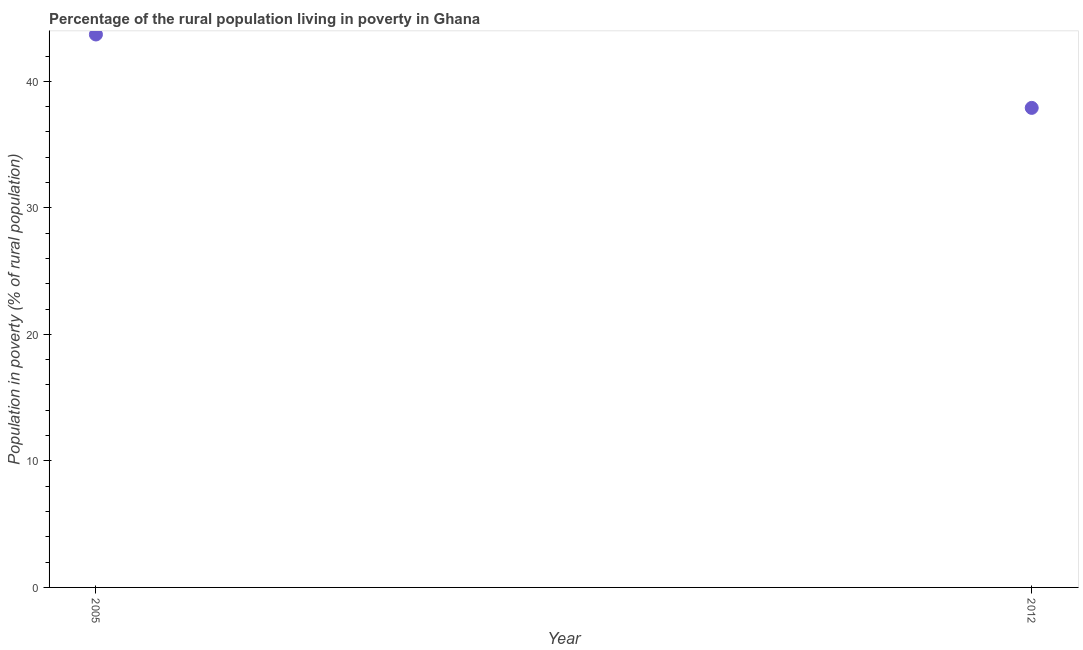What is the percentage of rural population living below poverty line in 2005?
Make the answer very short. 43.7. Across all years, what is the maximum percentage of rural population living below poverty line?
Provide a short and direct response. 43.7. Across all years, what is the minimum percentage of rural population living below poverty line?
Keep it short and to the point. 37.9. In which year was the percentage of rural population living below poverty line maximum?
Your answer should be very brief. 2005. In which year was the percentage of rural population living below poverty line minimum?
Keep it short and to the point. 2012. What is the sum of the percentage of rural population living below poverty line?
Give a very brief answer. 81.6. What is the difference between the percentage of rural population living below poverty line in 2005 and 2012?
Your answer should be very brief. 5.8. What is the average percentage of rural population living below poverty line per year?
Your response must be concise. 40.8. What is the median percentage of rural population living below poverty line?
Make the answer very short. 40.8. In how many years, is the percentage of rural population living below poverty line greater than 26 %?
Your answer should be very brief. 2. Do a majority of the years between 2012 and 2005 (inclusive) have percentage of rural population living below poverty line greater than 26 %?
Ensure brevity in your answer.  No. What is the ratio of the percentage of rural population living below poverty line in 2005 to that in 2012?
Your answer should be very brief. 1.15. Is the percentage of rural population living below poverty line in 2005 less than that in 2012?
Offer a terse response. No. In how many years, is the percentage of rural population living below poverty line greater than the average percentage of rural population living below poverty line taken over all years?
Give a very brief answer. 1. How many years are there in the graph?
Make the answer very short. 2. Does the graph contain any zero values?
Give a very brief answer. No. What is the title of the graph?
Give a very brief answer. Percentage of the rural population living in poverty in Ghana. What is the label or title of the Y-axis?
Your response must be concise. Population in poverty (% of rural population). What is the Population in poverty (% of rural population) in 2005?
Provide a short and direct response. 43.7. What is the Population in poverty (% of rural population) in 2012?
Give a very brief answer. 37.9. What is the difference between the Population in poverty (% of rural population) in 2005 and 2012?
Make the answer very short. 5.8. What is the ratio of the Population in poverty (% of rural population) in 2005 to that in 2012?
Make the answer very short. 1.15. 